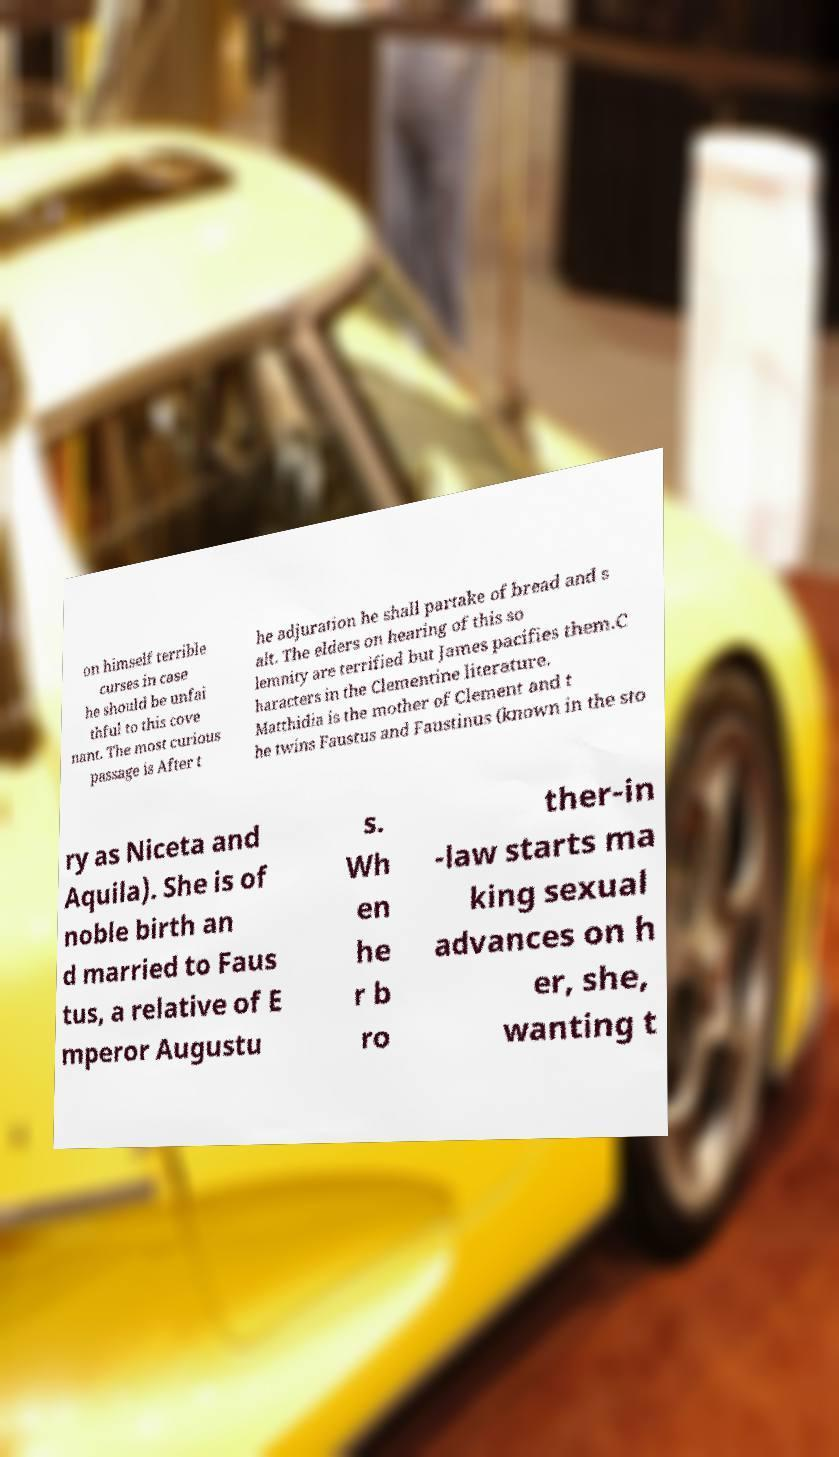Please read and relay the text visible in this image. What does it say? on himself terrible curses in case he should be unfai thful to this cove nant. The most curious passage is After t he adjuration he shall partake of bread and s alt. The elders on hearing of this so lemnity are terrified but James pacifies them.C haracters in the Clementine literature. Matthidia is the mother of Clement and t he twins Faustus and Faustinus (known in the sto ry as Niceta and Aquila). She is of noble birth an d married to Faus tus, a relative of E mperor Augustu s. Wh en he r b ro ther-in -law starts ma king sexual advances on h er, she, wanting t 